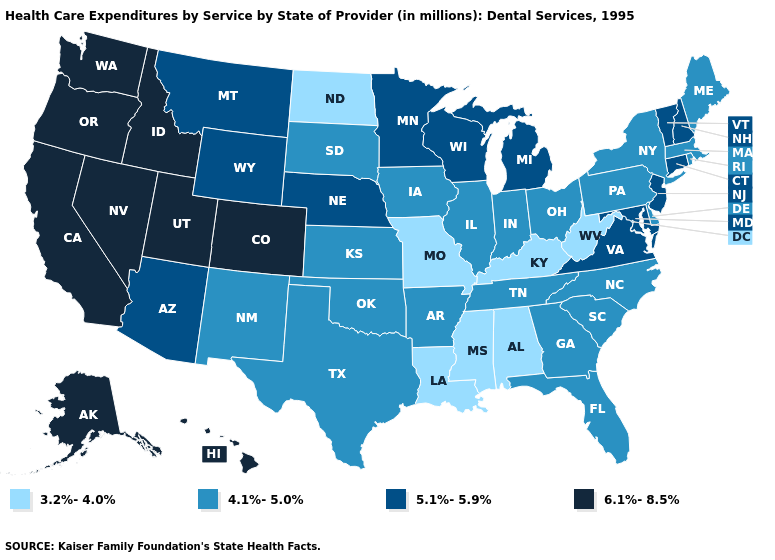Does Hawaii have a higher value than Washington?
Be succinct. No. Among the states that border Minnesota , does North Dakota have the highest value?
Be succinct. No. Name the states that have a value in the range 5.1%-5.9%?
Write a very short answer. Arizona, Connecticut, Maryland, Michigan, Minnesota, Montana, Nebraska, New Hampshire, New Jersey, Vermont, Virginia, Wisconsin, Wyoming. Which states have the lowest value in the USA?
Keep it brief. Alabama, Kentucky, Louisiana, Mississippi, Missouri, North Dakota, West Virginia. What is the highest value in states that border Pennsylvania?
Keep it brief. 5.1%-5.9%. Does the first symbol in the legend represent the smallest category?
Answer briefly. Yes. Among the states that border Maryland , does Virginia have the highest value?
Quick response, please. Yes. What is the value of Alaska?
Be succinct. 6.1%-8.5%. Name the states that have a value in the range 4.1%-5.0%?
Give a very brief answer. Arkansas, Delaware, Florida, Georgia, Illinois, Indiana, Iowa, Kansas, Maine, Massachusetts, New Mexico, New York, North Carolina, Ohio, Oklahoma, Pennsylvania, Rhode Island, South Carolina, South Dakota, Tennessee, Texas. Among the states that border California , does Arizona have the highest value?
Keep it brief. No. What is the value of North Dakota?
Answer briefly. 3.2%-4.0%. What is the value of Minnesota?
Quick response, please. 5.1%-5.9%. Among the states that border Maryland , which have the lowest value?
Quick response, please. West Virginia. Name the states that have a value in the range 5.1%-5.9%?
Give a very brief answer. Arizona, Connecticut, Maryland, Michigan, Minnesota, Montana, Nebraska, New Hampshire, New Jersey, Vermont, Virginia, Wisconsin, Wyoming. Name the states that have a value in the range 5.1%-5.9%?
Quick response, please. Arizona, Connecticut, Maryland, Michigan, Minnesota, Montana, Nebraska, New Hampshire, New Jersey, Vermont, Virginia, Wisconsin, Wyoming. 